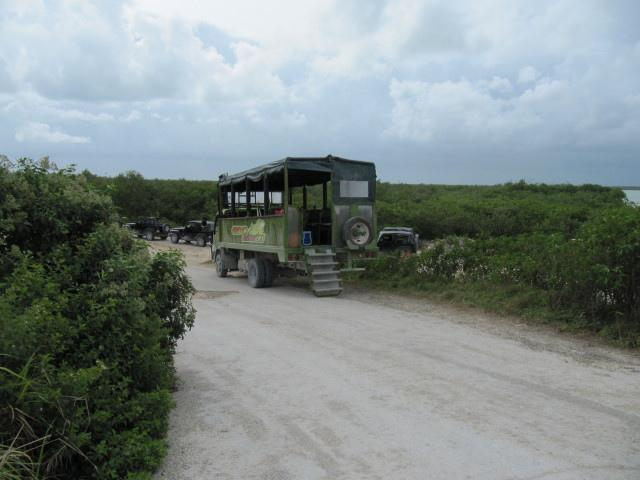What does the truck have a spare of on the back? Please explain your reasoning. tire. There is a tire on the back of the truck. 